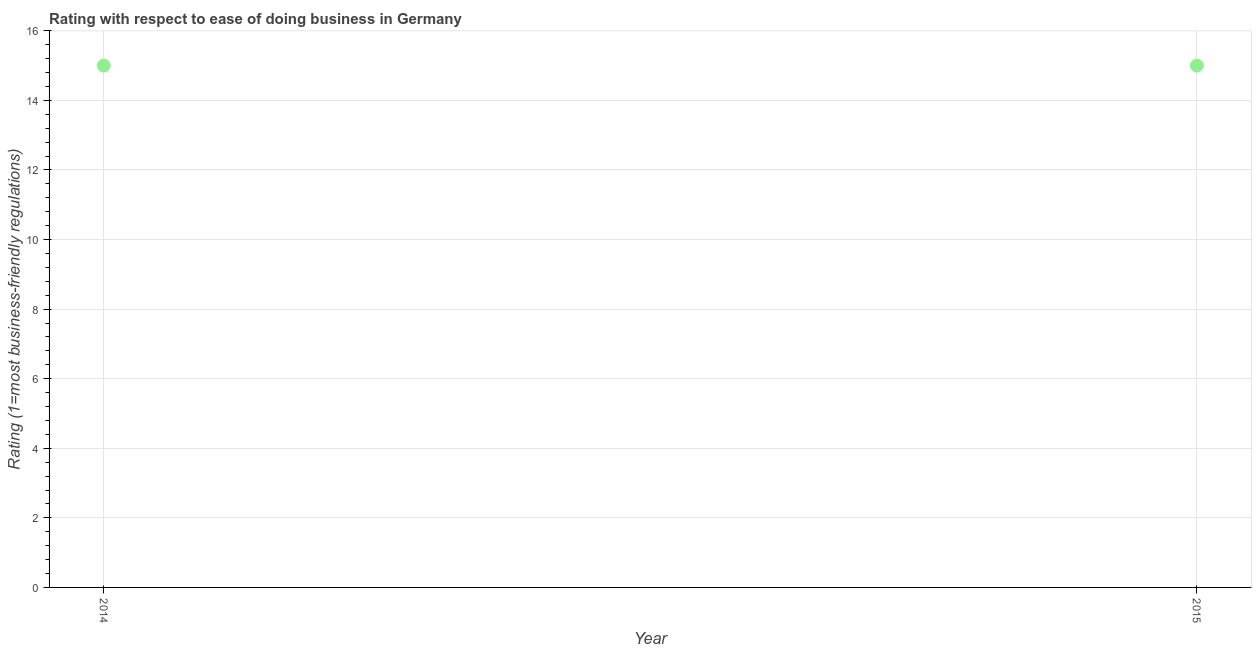What is the ease of doing business index in 2014?
Give a very brief answer. 15. Across all years, what is the maximum ease of doing business index?
Your answer should be compact. 15. Across all years, what is the minimum ease of doing business index?
Offer a very short reply. 15. In which year was the ease of doing business index minimum?
Your answer should be compact. 2014. What is the sum of the ease of doing business index?
Your answer should be compact. 30. What is the difference between the ease of doing business index in 2014 and 2015?
Keep it short and to the point. 0. What is the average ease of doing business index per year?
Your answer should be compact. 15. In how many years, is the ease of doing business index greater than 14.8 ?
Offer a very short reply. 2. In how many years, is the ease of doing business index greater than the average ease of doing business index taken over all years?
Your answer should be compact. 0. Does the ease of doing business index monotonically increase over the years?
Provide a short and direct response. No. How many years are there in the graph?
Provide a succinct answer. 2. What is the difference between two consecutive major ticks on the Y-axis?
Offer a very short reply. 2. Does the graph contain any zero values?
Provide a succinct answer. No. What is the title of the graph?
Give a very brief answer. Rating with respect to ease of doing business in Germany. What is the label or title of the X-axis?
Keep it short and to the point. Year. What is the label or title of the Y-axis?
Ensure brevity in your answer.  Rating (1=most business-friendly regulations). What is the Rating (1=most business-friendly regulations) in 2014?
Your answer should be compact. 15. 